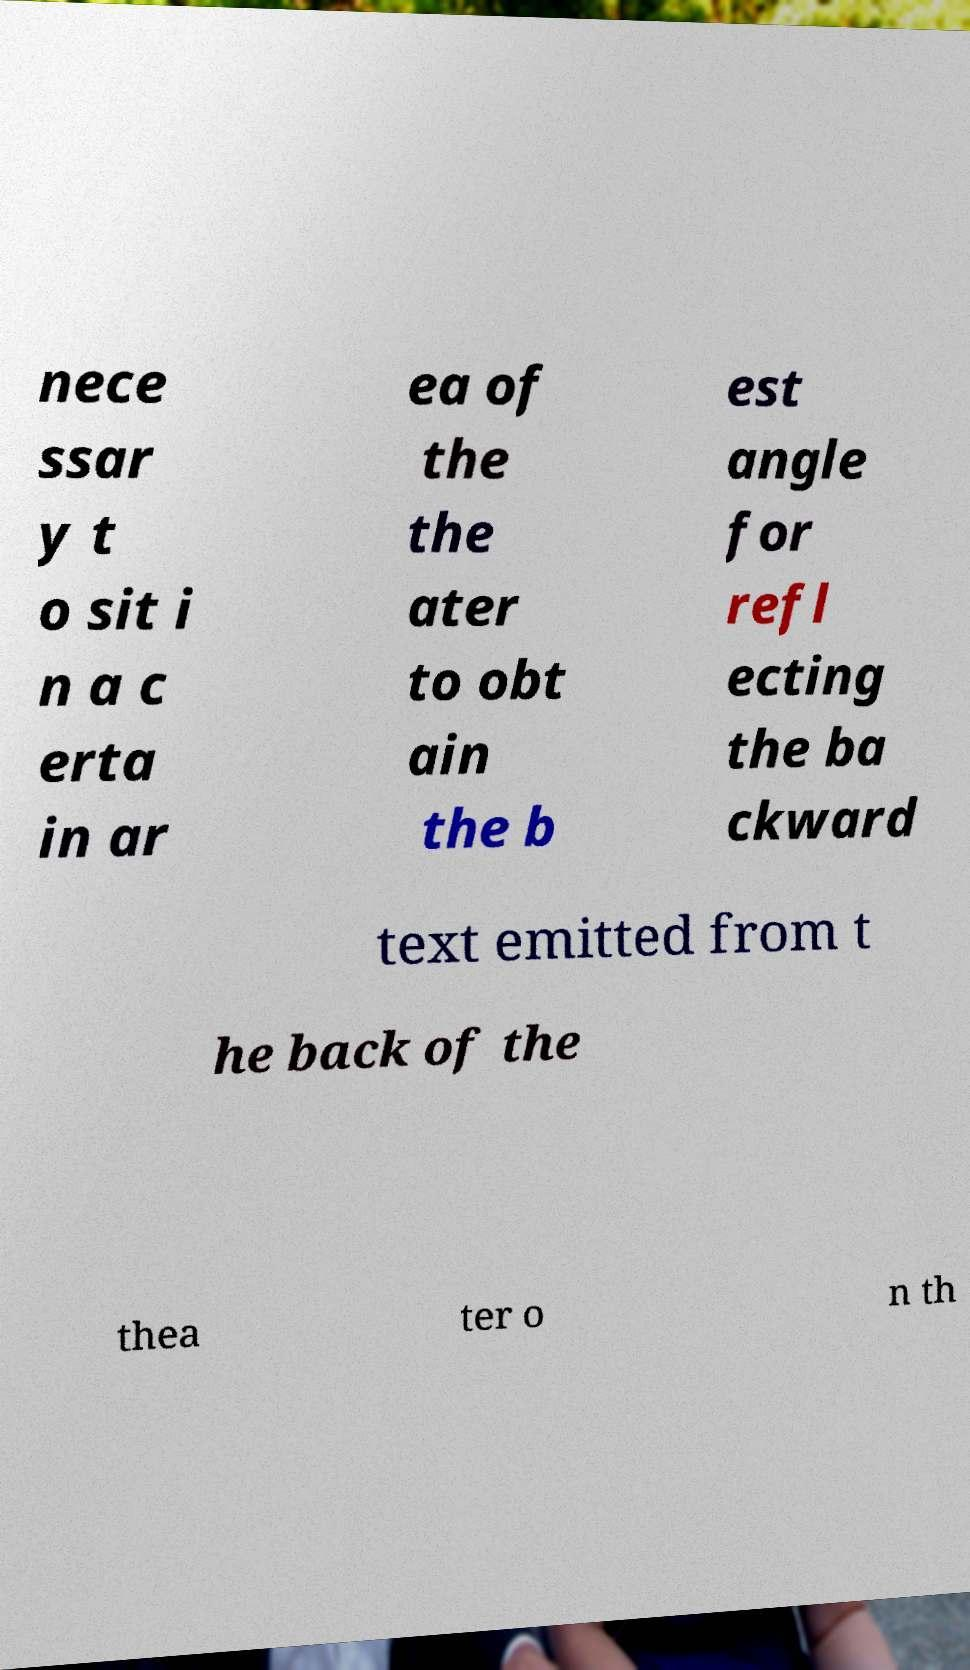Can you accurately transcribe the text from the provided image for me? nece ssar y t o sit i n a c erta in ar ea of the the ater to obt ain the b est angle for refl ecting the ba ckward text emitted from t he back of the thea ter o n th 